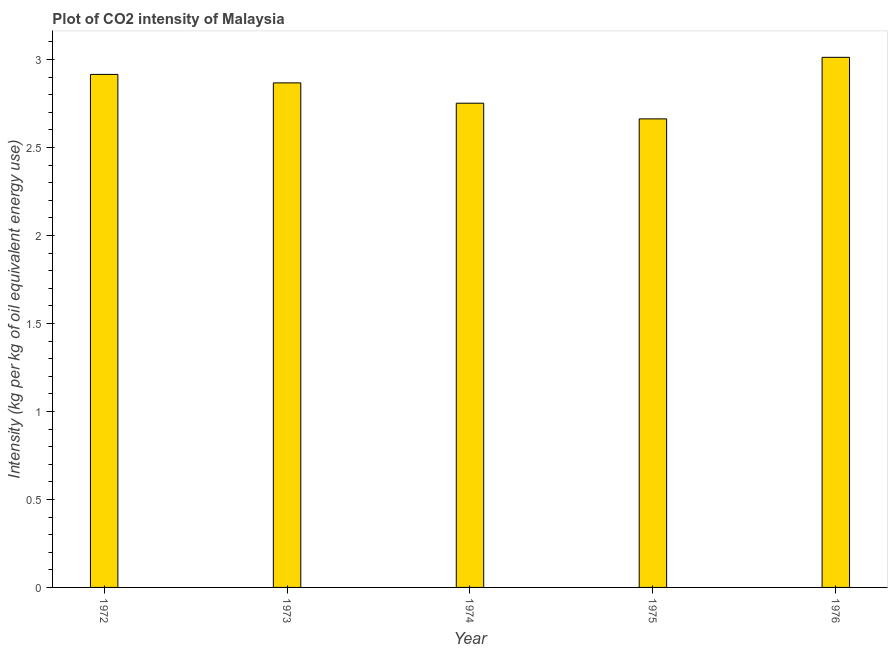What is the title of the graph?
Give a very brief answer. Plot of CO2 intensity of Malaysia. What is the label or title of the Y-axis?
Give a very brief answer. Intensity (kg per kg of oil equivalent energy use). What is the co2 intensity in 1973?
Your answer should be very brief. 2.87. Across all years, what is the maximum co2 intensity?
Give a very brief answer. 3.01. Across all years, what is the minimum co2 intensity?
Provide a succinct answer. 2.66. In which year was the co2 intensity maximum?
Ensure brevity in your answer.  1976. In which year was the co2 intensity minimum?
Offer a very short reply. 1975. What is the sum of the co2 intensity?
Provide a short and direct response. 14.21. What is the difference between the co2 intensity in 1972 and 1973?
Your answer should be compact. 0.05. What is the average co2 intensity per year?
Offer a terse response. 2.84. What is the median co2 intensity?
Offer a terse response. 2.87. What is the ratio of the co2 intensity in 1973 to that in 1974?
Provide a short and direct response. 1.04. Is the co2 intensity in 1973 less than that in 1976?
Your answer should be very brief. Yes. What is the difference between the highest and the second highest co2 intensity?
Ensure brevity in your answer.  0.1. Is the sum of the co2 intensity in 1972 and 1976 greater than the maximum co2 intensity across all years?
Your answer should be very brief. Yes. What is the difference between the highest and the lowest co2 intensity?
Give a very brief answer. 0.35. How many bars are there?
Ensure brevity in your answer.  5. Are all the bars in the graph horizontal?
Offer a very short reply. No. Are the values on the major ticks of Y-axis written in scientific E-notation?
Keep it short and to the point. No. What is the Intensity (kg per kg of oil equivalent energy use) in 1972?
Ensure brevity in your answer.  2.92. What is the Intensity (kg per kg of oil equivalent energy use) in 1973?
Offer a very short reply. 2.87. What is the Intensity (kg per kg of oil equivalent energy use) in 1974?
Offer a very short reply. 2.75. What is the Intensity (kg per kg of oil equivalent energy use) of 1975?
Offer a terse response. 2.66. What is the Intensity (kg per kg of oil equivalent energy use) of 1976?
Provide a succinct answer. 3.01. What is the difference between the Intensity (kg per kg of oil equivalent energy use) in 1972 and 1973?
Make the answer very short. 0.05. What is the difference between the Intensity (kg per kg of oil equivalent energy use) in 1972 and 1974?
Keep it short and to the point. 0.16. What is the difference between the Intensity (kg per kg of oil equivalent energy use) in 1972 and 1975?
Ensure brevity in your answer.  0.25. What is the difference between the Intensity (kg per kg of oil equivalent energy use) in 1972 and 1976?
Offer a very short reply. -0.1. What is the difference between the Intensity (kg per kg of oil equivalent energy use) in 1973 and 1974?
Make the answer very short. 0.12. What is the difference between the Intensity (kg per kg of oil equivalent energy use) in 1973 and 1975?
Ensure brevity in your answer.  0.2. What is the difference between the Intensity (kg per kg of oil equivalent energy use) in 1973 and 1976?
Your response must be concise. -0.15. What is the difference between the Intensity (kg per kg of oil equivalent energy use) in 1974 and 1975?
Give a very brief answer. 0.09. What is the difference between the Intensity (kg per kg of oil equivalent energy use) in 1974 and 1976?
Your response must be concise. -0.26. What is the difference between the Intensity (kg per kg of oil equivalent energy use) in 1975 and 1976?
Keep it short and to the point. -0.35. What is the ratio of the Intensity (kg per kg of oil equivalent energy use) in 1972 to that in 1973?
Ensure brevity in your answer.  1.02. What is the ratio of the Intensity (kg per kg of oil equivalent energy use) in 1972 to that in 1974?
Provide a succinct answer. 1.06. What is the ratio of the Intensity (kg per kg of oil equivalent energy use) in 1972 to that in 1975?
Your response must be concise. 1.09. What is the ratio of the Intensity (kg per kg of oil equivalent energy use) in 1972 to that in 1976?
Your answer should be very brief. 0.97. What is the ratio of the Intensity (kg per kg of oil equivalent energy use) in 1973 to that in 1974?
Provide a succinct answer. 1.04. What is the ratio of the Intensity (kg per kg of oil equivalent energy use) in 1973 to that in 1975?
Your answer should be compact. 1.08. What is the ratio of the Intensity (kg per kg of oil equivalent energy use) in 1974 to that in 1975?
Your answer should be very brief. 1.03. What is the ratio of the Intensity (kg per kg of oil equivalent energy use) in 1975 to that in 1976?
Your answer should be compact. 0.88. 